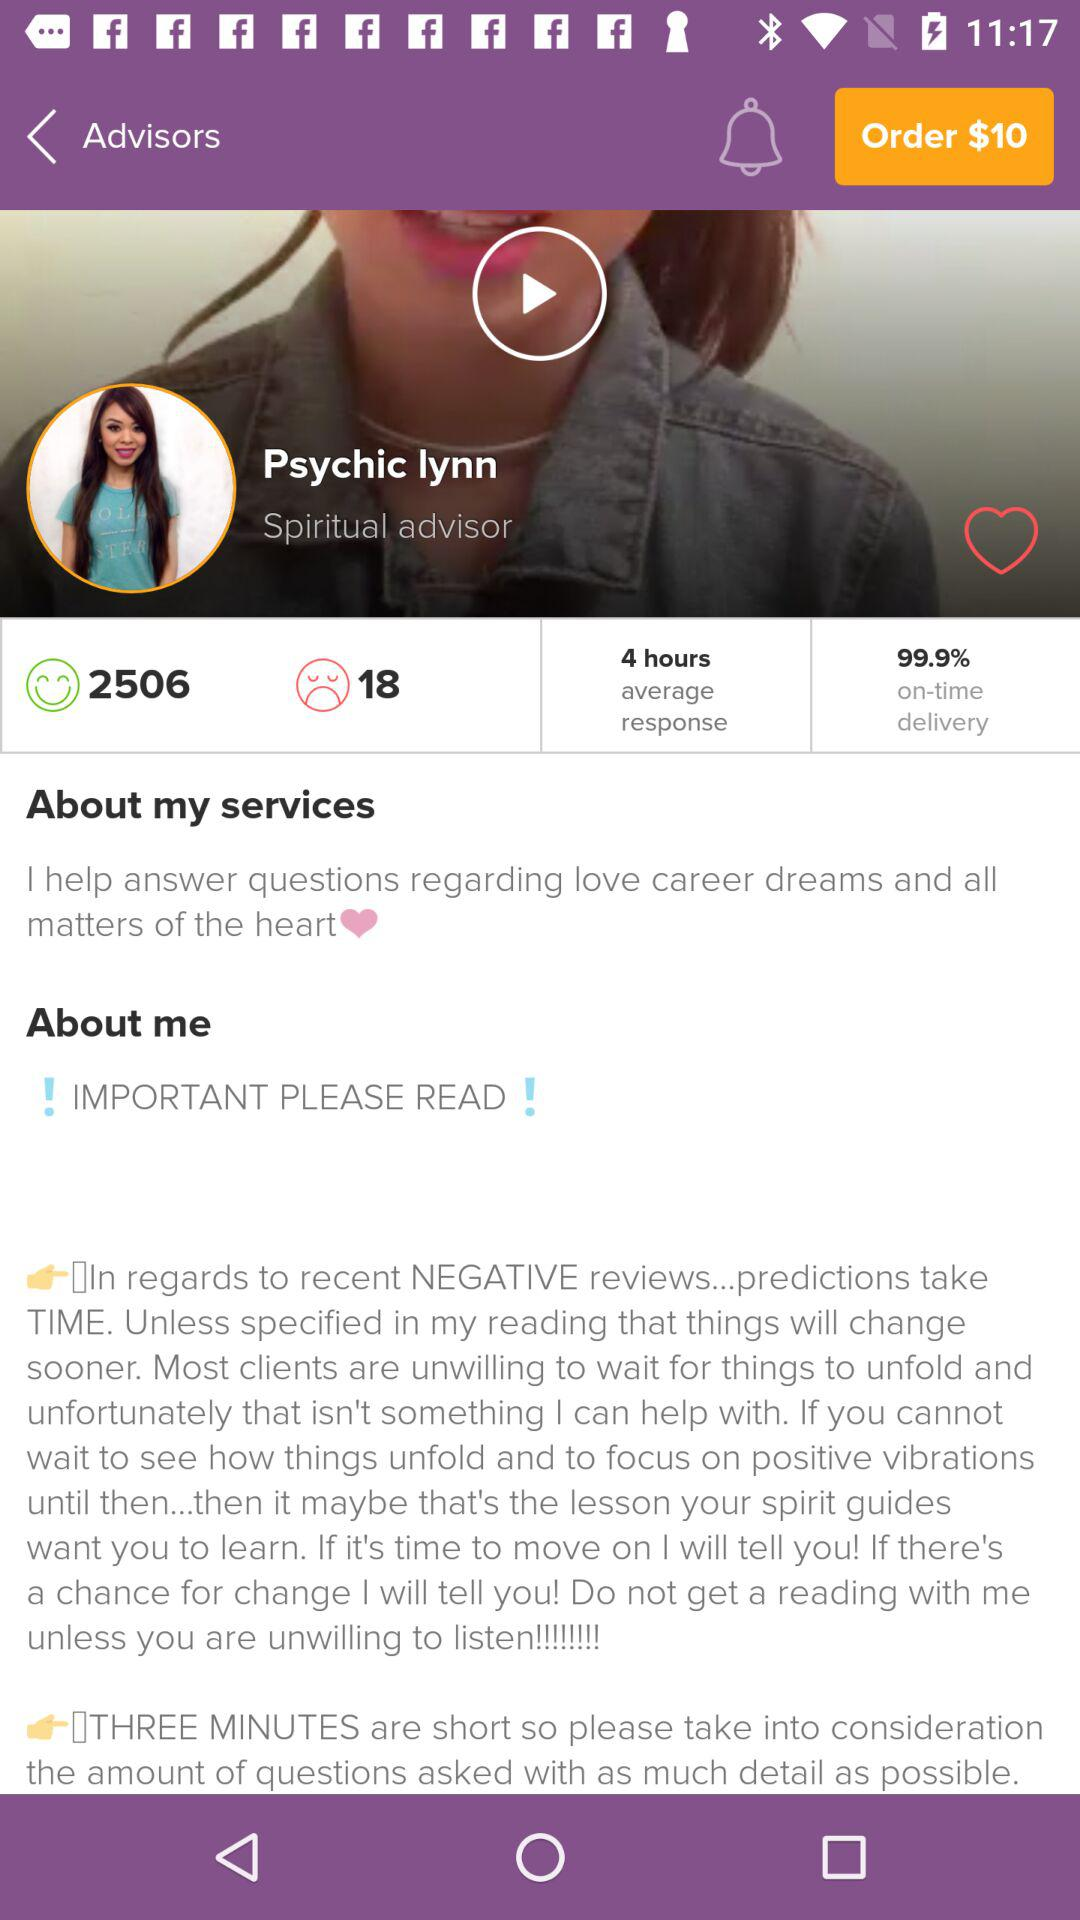What is the order price? The order price is $10. 